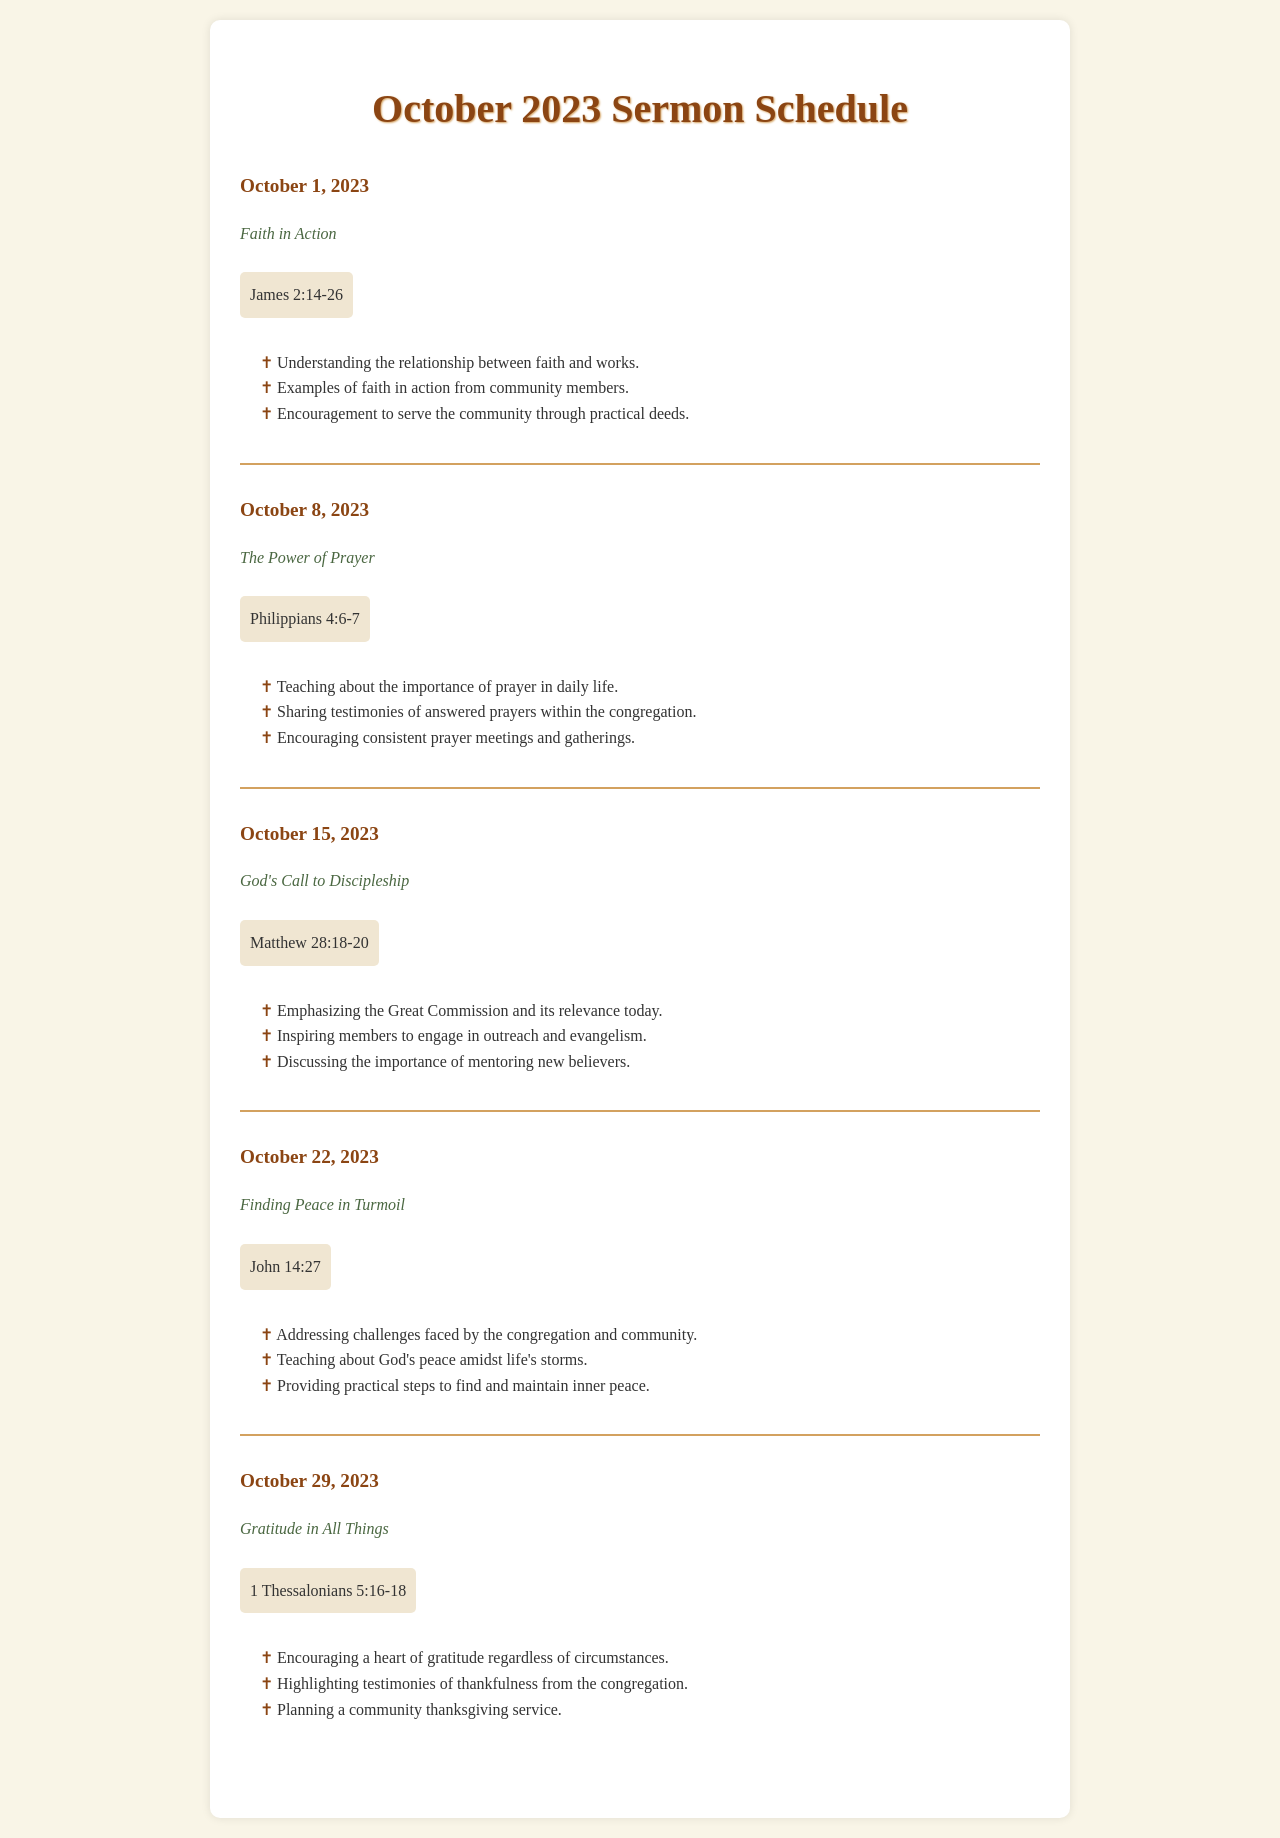What is the theme for October 1, 2023? The theme for October 1, 2023, is stated directly under the date in the document.
Answer: Faith in Action What scripture reference is associated with the theme "The Power of Prayer"? The scripture reference is mentioned next to the theme for each respective date in the document.
Answer: Philippians 4:6-7 Which date is dedicated to "Finding Peace in Turmoil"? The document specifies the date for each theme clearly, allowing easy identification of the date for any given theme.
Answer: October 22, 2023 How many sermon themes are listed for October 2023? The total number of themes can be counted by reviewing the number of sermon entries in the document.
Answer: Five What is one of the main points for the theme "God's Call to Discipleship"? Points under each theme outline significant messages, allowing retrieval of specific insights under each theme.
Answer: Emphasizing the Great Commission and its relevance today What is the last theme scheduled for October 2023? The last theme is found at the end of the documented schedule, detailing the final entry for the month.
Answer: Gratitude in All Things What scripture is referenced for the theme "Gratitude in All Things"? The scripture reference is located right after the theme for each respective Sunday in the document.
Answer: 1 Thessalonians 5:16-18 What kind of service is planned in connection with the theme of gratitude? The document contains specific planned activities associated with each theme, which include special services or community gatherings.
Answer: Community thanksgiving service 